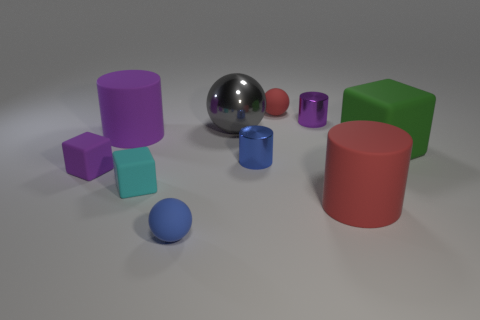Subtract all cylinders. How many objects are left? 6 Subtract all big cyan metal objects. Subtract all metal objects. How many objects are left? 7 Add 3 large shiny spheres. How many large shiny spheres are left? 4 Add 5 big red matte objects. How many big red matte objects exist? 6 Subtract 0 cyan cylinders. How many objects are left? 10 